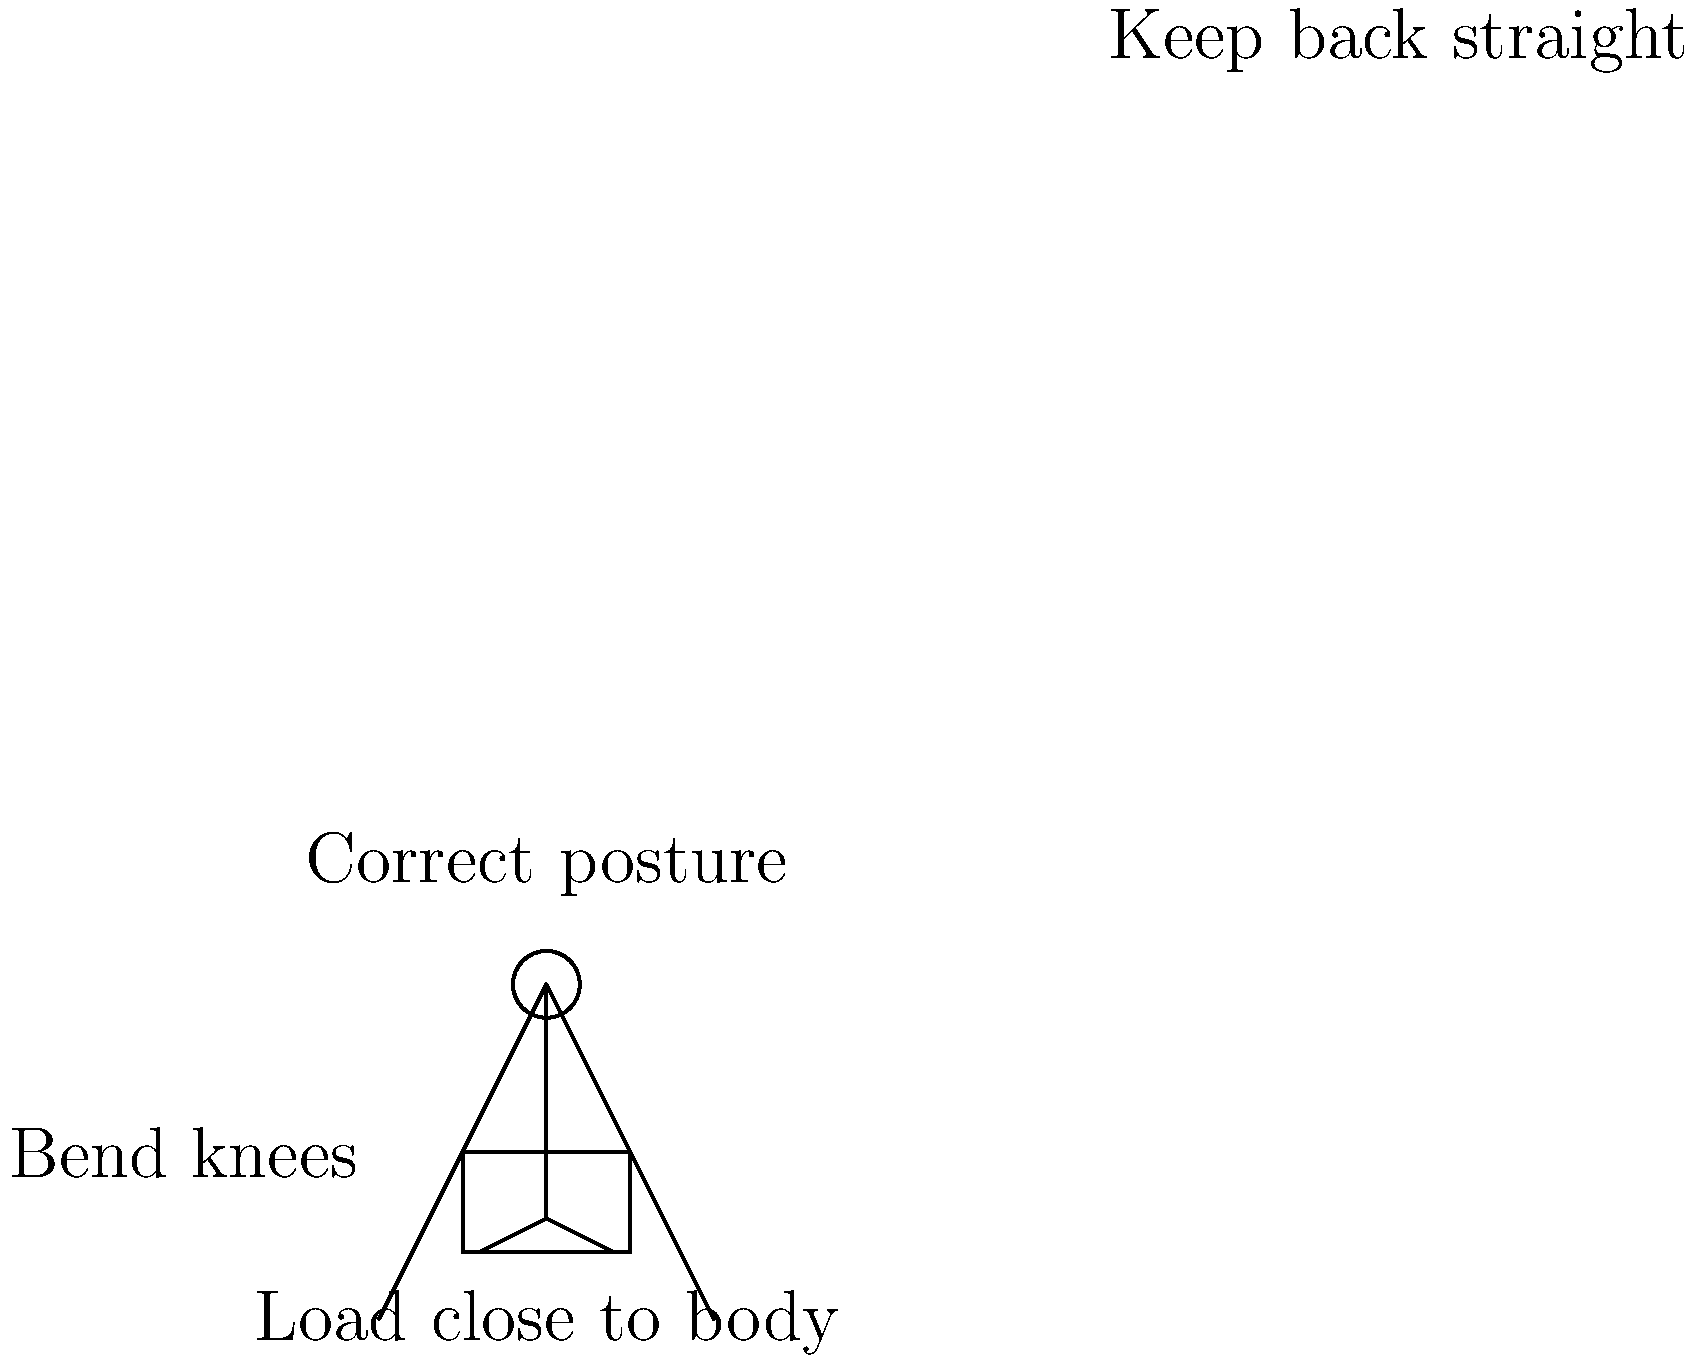During a community service project, you need to lift and carry heavy boxes of donated items. Which of the following biomechanical principles is most important for preventing back injuries when lifting these objects?

A) Keeping your arms fully extended
B) Twisting your torso while lifting
C) Bending at the waist to reach the object
D) Keeping the object close to your body To safely lift and carry heavy objects, it's important to follow proper biomechanical principles:

1. Bend your knees and hips, not your back: This distributes the load more evenly and reduces strain on your lower back.

2. Keep your back straight: Maintaining a neutral spine position helps prevent excessive stress on your vertebrae and intervertebral discs.

3. Keep the object close to your body: This minimizes the moment arm, reducing the torque on your spine and the effort required to lift.

4. Avoid twisting: Twisting while lifting can increase the risk of disc injuries.

5. Use your leg muscles: They are stronger than your back muscles and better suited for lifting.

6. Maintain a stable base: Keep your feet shoulder-width apart for balance.

The most critical principle among these options is keeping the object close to your body. This significantly reduces the load on your spine by minimizing the moment arm. The force (F) required to lift an object is given by:

$$F = \frac{m \cdot g \cdot d}{L}$$

Where:
$m$ = mass of the object
$g$ = acceleration due to gravity
$d$ = distance from the center of mass of the object to the axis of rotation (spine)
$L$ = length of the lever arm (distance from the axis of rotation to the point of force application)

By keeping the object close (minimizing $d$), you reduce the required force and the stress on your back.
Answer: D) Keeping the object close to your body 